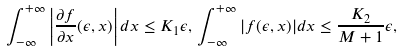<formula> <loc_0><loc_0><loc_500><loc_500>\int _ { - \infty } ^ { + \infty } \left | \frac { \partial f } { \partial x } ( \epsilon , x ) \right | d x \leq K _ { 1 } \epsilon , \, \int _ { - \infty } ^ { + \infty } | f ( \epsilon , x ) | d x \leq \frac { K _ { 2 } } { M + 1 } \epsilon ,</formula> 